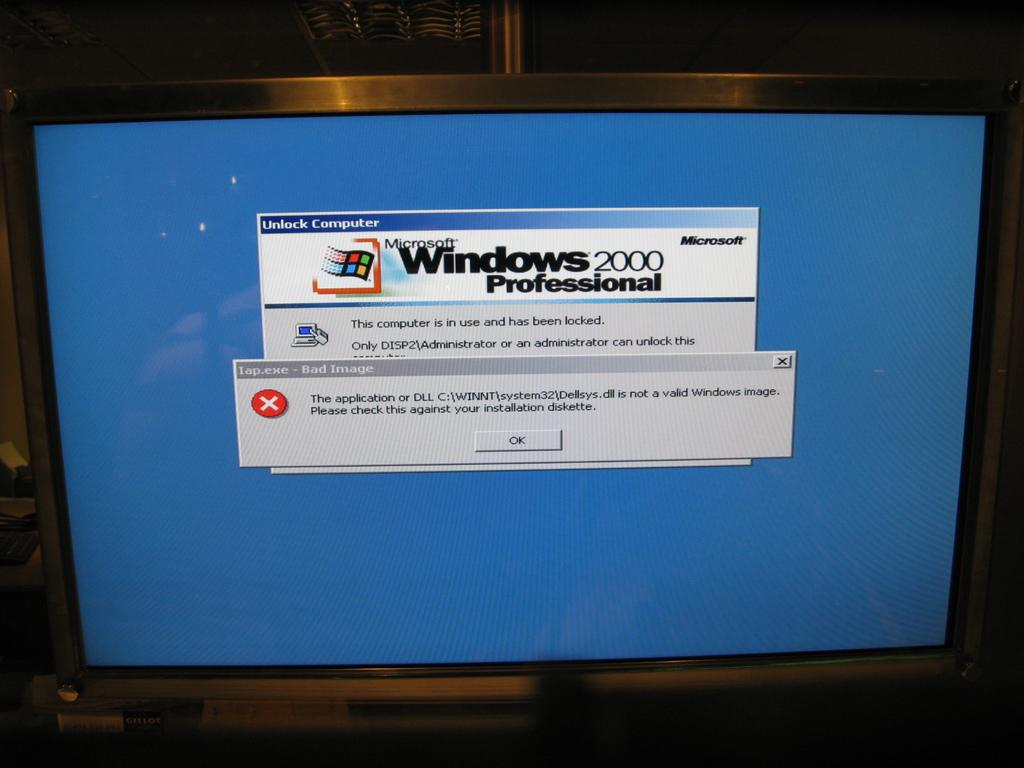<image>
Share a concise interpretation of the image provided. Computer monitor with windows 2000 professional on it 